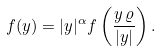<formula> <loc_0><loc_0><loc_500><loc_500>f ( y ) = | y | ^ { \alpha } f \left ( \frac { y \, \varrho } { | y | } \right ) .</formula> 